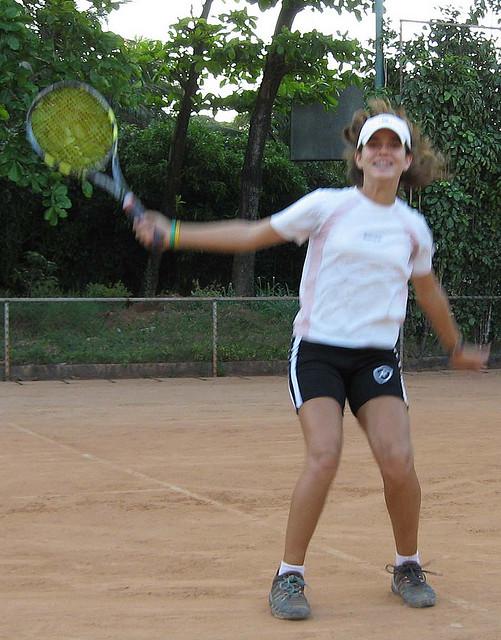What color are her shorts?
Keep it brief. Black. What color are the racket strings?
Be succinct. Yellow. Is she wearing a cap?
Answer briefly. Yes. What logo is on the women's shorts?
Concise answer only. Adidas. 